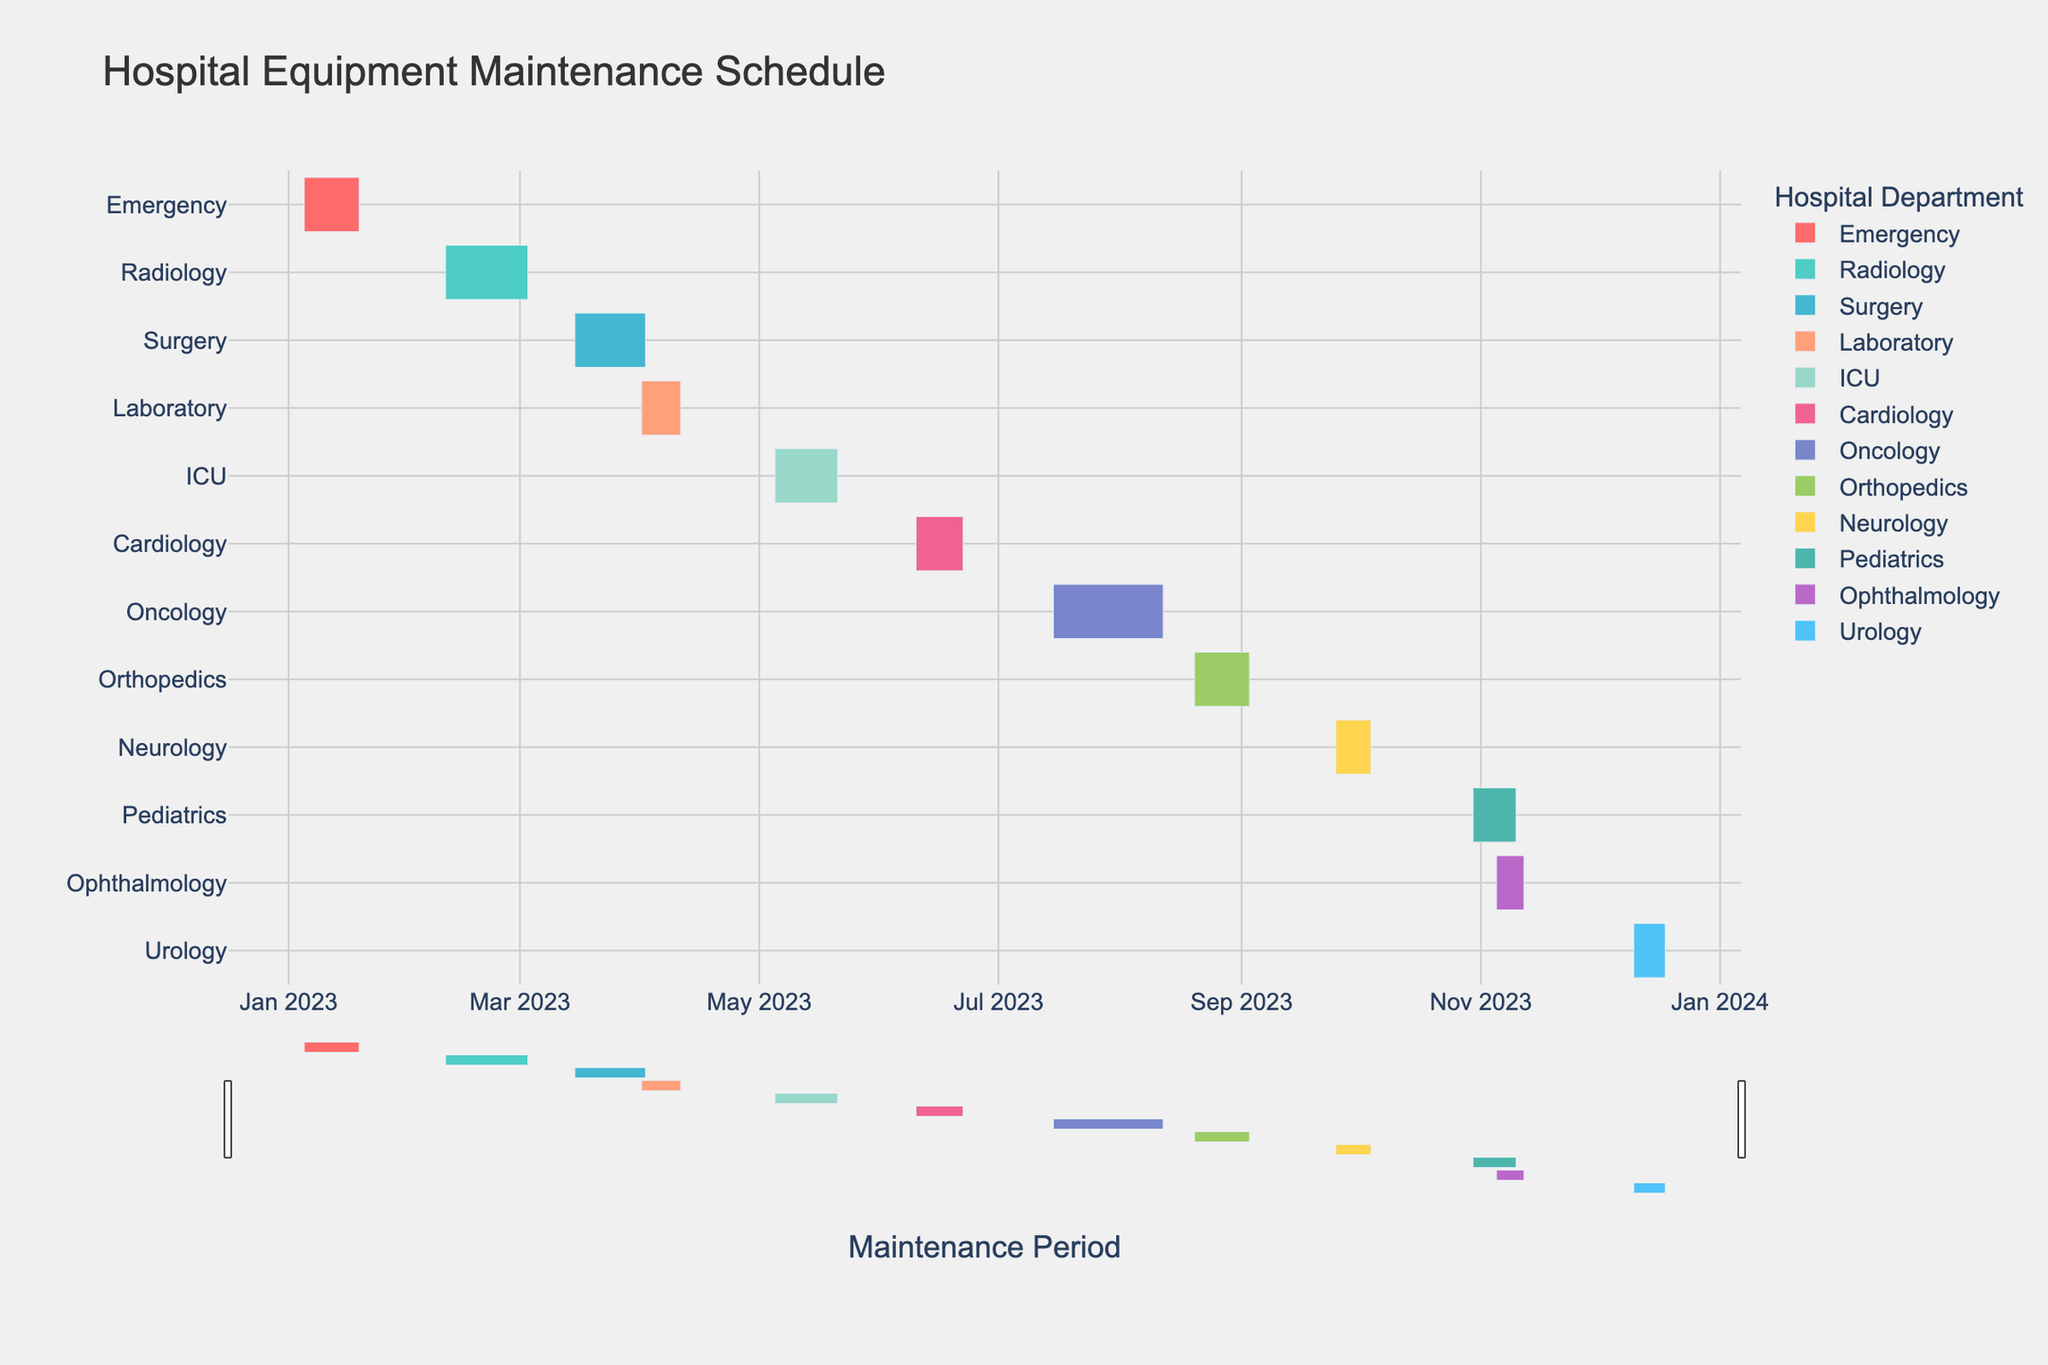What is the duration of maintenance for the MRI Scanner in Radiology? The Gantt chart shows the durations of maintenance tasks for each piece of equipment. For the MRI Scanner in Radiology, the duration is displayed as 21 days.
Answer: 21 days Which department has the earliest maintenance start date, and which equipment does it involve? By looking at the starting dates on the Gantt chart, the earliest maintenance task starts on January 5th and involves the Defibrillators in the Emergency department.
Answer: Emergency, Defibrillators What is the total duration of maintenance tasks planned for the first half of the year (January to June)? To find the total duration, check the durations of maintenance tasks from January to June: Emergency (14 days) + Radiology (21 days) + Surgery (18 days) + Laboratory (10 days) + ICU (16 days) + Cardiology (12 days). Summing these gives a total of 91 days.
Answer: 91 days Which equipment has the longest maintenance period, and how many days does it last? The Gantt chart shows the duration of each equipment's maintenance. The Linear Accelerator in Oncology has the longest maintenance period of 28 days.
Answer: Linear Accelerator, 28 days How does the maintenance duration of Ventilators in ICU compare to that of EEG Equipment in Neurology? The maintenance duration for Ventilators in ICU is displayed as 16 days, while the EEG Equipment in Neurology has a duration of 9 days. Comparing these, the ICU's Ventilators have a longer maintenance period.
Answer: ICU's Ventilators are longer (16 days vs. 9 days) Calculate the average duration of all maintenance tasks across departments. Sum the durations of all maintenance tasks (14 + 21 + 18 + 10 + 16 + 12 + 28 + 14 + 9 + 11 + 7 + 8) which equals 168 days. There are 12 maintenance tasks, so the average duration is 168 / 12 = 14 days.
Answer: 14 days Which department starts its maintenance in October, and what is the duration of the maintenance? The Gantt chart indicates that Pediatrics starts its maintenance in October 30th, and it involves Infant Incubators with a duration of 11 days.
Answer: Pediatrics, 11 days Are there any overlapping maintenance periods across departments? If so, which ones? By examining the start and end dates on the Gantt chart, there are overlapping maintenance periods. For example, the Radiology department (MRI Scanner) overlaps with Surgery (Anesthesia Machines): Radiology’s maintenance goes from February 10 to March 3, and Surgery's starts on March 15. Conclusively, no overlapping works.
Answer: No overlapping maintenance In which month does the most number of maintenance activities start, and how many activities start in that month? By reviewing the start dates for each maintenance task, June has only one maintenance activity.
Answer: Only one activity in each month 